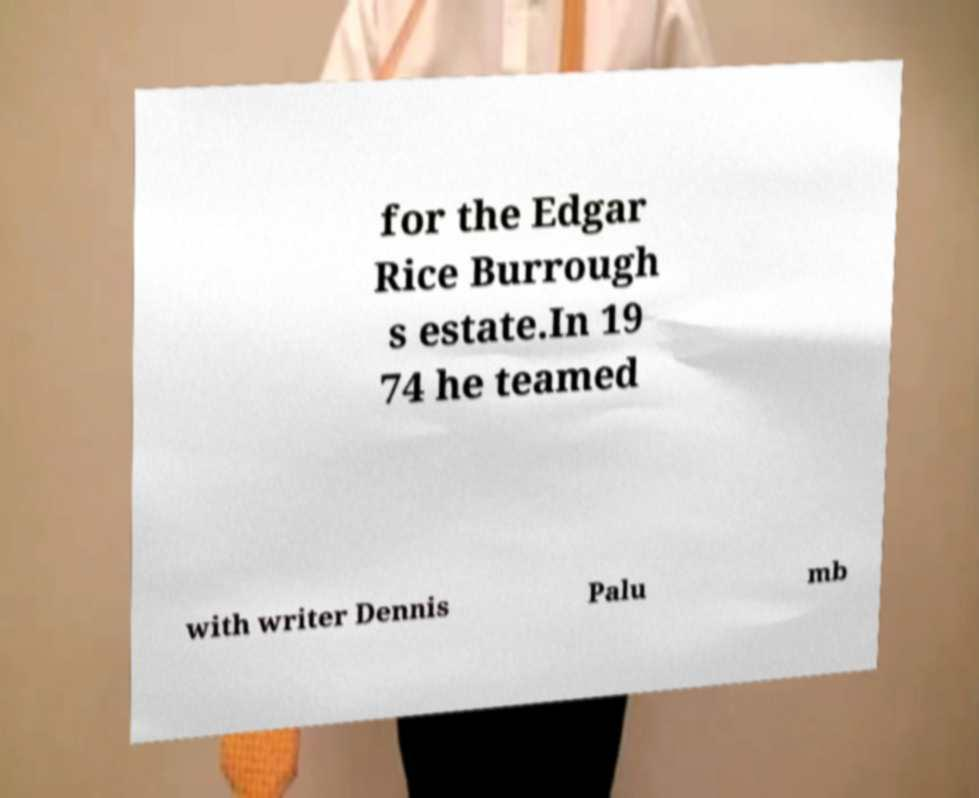Can you accurately transcribe the text from the provided image for me? for the Edgar Rice Burrough s estate.In 19 74 he teamed with writer Dennis Palu mb 